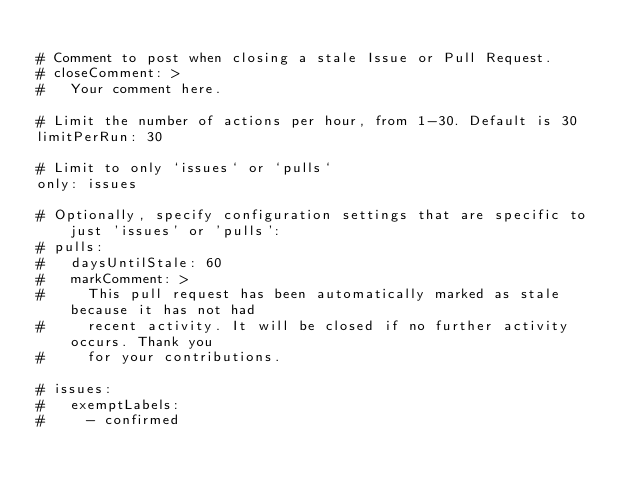<code> <loc_0><loc_0><loc_500><loc_500><_YAML_>
# Comment to post when closing a stale Issue or Pull Request.
# closeComment: >
#   Your comment here.

# Limit the number of actions per hour, from 1-30. Default is 30
limitPerRun: 30

# Limit to only `issues` or `pulls`
only: issues

# Optionally, specify configuration settings that are specific to just 'issues' or 'pulls':
# pulls:
#   daysUntilStale: 60
#   markComment: >
#     This pull request has been automatically marked as stale because it has not had
#     recent activity. It will be closed if no further activity occurs. Thank you
#     for your contributions.

# issues:
#   exemptLabels:
#     - confirmed
</code> 